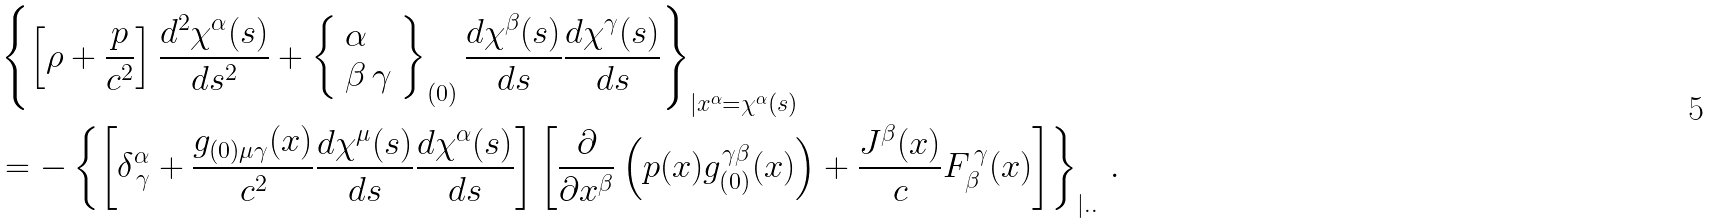<formula> <loc_0><loc_0><loc_500><loc_500>& \left \{ \left [ \rho + \frac { p } { c ^ { 2 } } \right ] \frac { d ^ { 2 } \chi ^ { \alpha } ( s ) } { d s ^ { 2 } } + \left \{ \begin{array} { l } \alpha \\ \beta \, \gamma \end{array} \right \} _ { ( 0 ) } \frac { d \chi ^ { \beta } ( s ) } { d s } \frac { d \chi ^ { \gamma } ( s ) } { d s } \right \} _ { | x ^ { \alpha } = \chi ^ { \alpha } ( s ) } \\ & = - \left \{ \left [ \delta ^ { \alpha } _ { \, \gamma } + \frac { g _ { ( 0 ) \mu \gamma } ( x ) } { c ^ { 2 } } \frac { d \chi ^ { \mu } ( s ) } { d s } \frac { d \chi ^ { \alpha } ( s ) } { d s } \right ] \left [ \frac { \partial } { \partial x ^ { \beta } } \left ( p ( x ) g _ { ( 0 ) } ^ { \gamma \beta } ( x ) \right ) + \frac { J ^ { \beta } ( x ) } { c } F _ { \beta } ^ { \, \gamma } ( x ) \right ] \right \} _ { | . . } \, .</formula> 